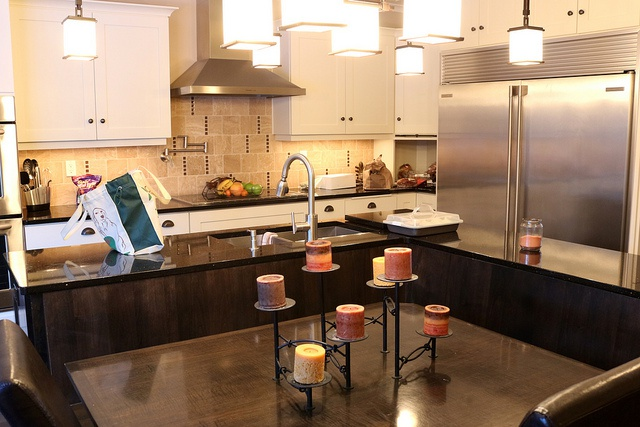Describe the objects in this image and their specific colors. I can see dining table in white, maroon, gray, and black tones, refrigerator in white, gray, tan, and darkgray tones, chair in white, black, gray, and maroon tones, chair in white, black, gray, brown, and maroon tones, and sink in white, maroon, and gray tones in this image. 